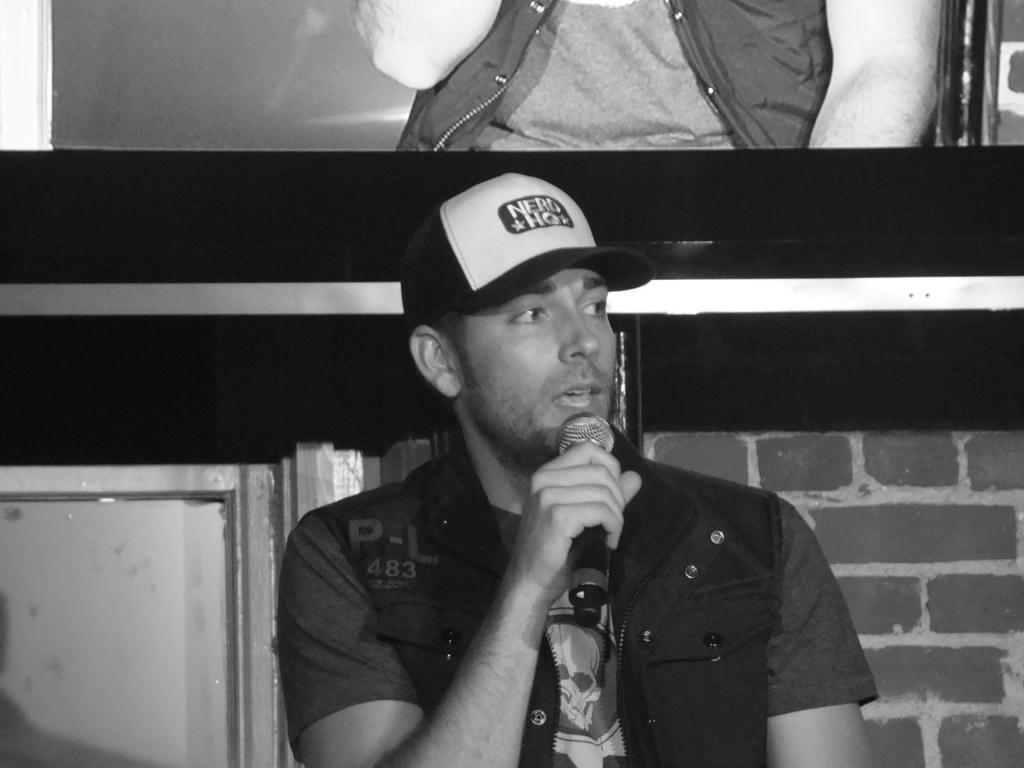Who is present in the image? There is a man in the image. What is the man holding in his hand? The man is holding a microphone in his hand. What type of weather can be seen on the moon in the image? There is no moon present in the image, and therefore no weather can be observed. 